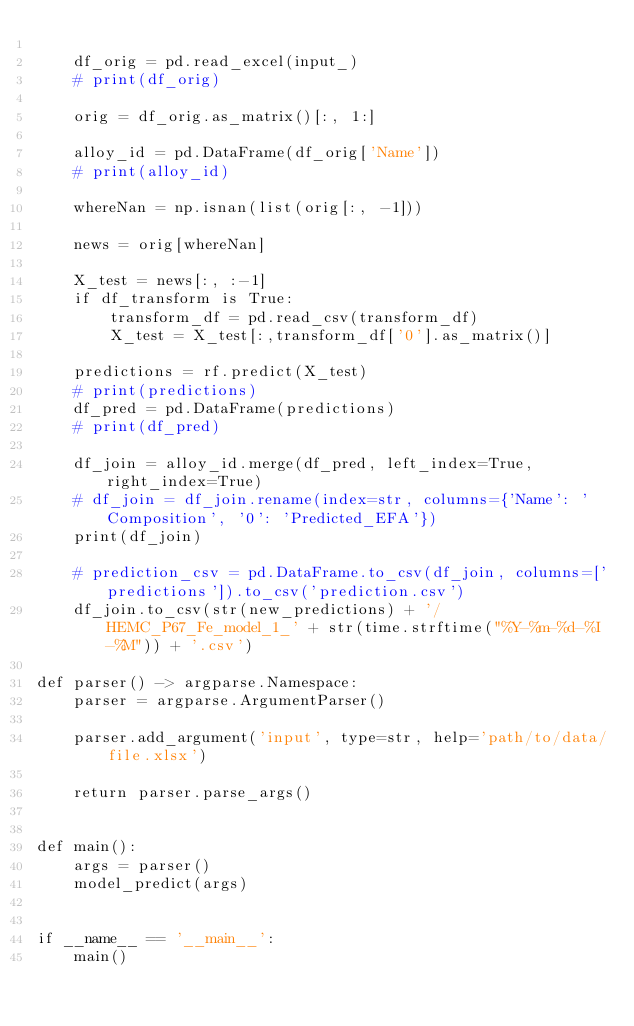<code> <loc_0><loc_0><loc_500><loc_500><_Python_>
    df_orig = pd.read_excel(input_)
    # print(df_orig)

    orig = df_orig.as_matrix()[:, 1:]

    alloy_id = pd.DataFrame(df_orig['Name'])
    # print(alloy_id)

    whereNan = np.isnan(list(orig[:, -1]))

    news = orig[whereNan]

    X_test = news[:, :-1]
    if df_transform is True:
        transform_df = pd.read_csv(transform_df)
        X_test = X_test[:,transform_df['0'].as_matrix()]

    predictions = rf.predict(X_test)
    # print(predictions)
    df_pred = pd.DataFrame(predictions)
    # print(df_pred)

    df_join = alloy_id.merge(df_pred, left_index=True, right_index=True)
    # df_join = df_join.rename(index=str, columns={'Name': 'Composition', '0': 'Predicted_EFA'})
    print(df_join)

    # prediction_csv = pd.DataFrame.to_csv(df_join, columns=['predictions']).to_csv('prediction.csv')
    df_join.to_csv(str(new_predictions) + '/HEMC_P67_Fe_model_1_' + str(time.strftime("%Y-%m-%d-%I-%M")) + '.csv')

def parser() -> argparse.Namespace:
    parser = argparse.ArgumentParser()

    parser.add_argument('input', type=str, help='path/to/data/file.xlsx')

    return parser.parse_args()


def main():
    args = parser()
    model_predict(args)


if __name__ == '__main__':
    main()
</code> 